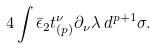<formula> <loc_0><loc_0><loc_500><loc_500>4 \int \bar { \epsilon } _ { 2 } t _ { ( p ) } ^ { \nu } \partial _ { \nu } \lambda \, d ^ { p + 1 } \sigma .</formula> 